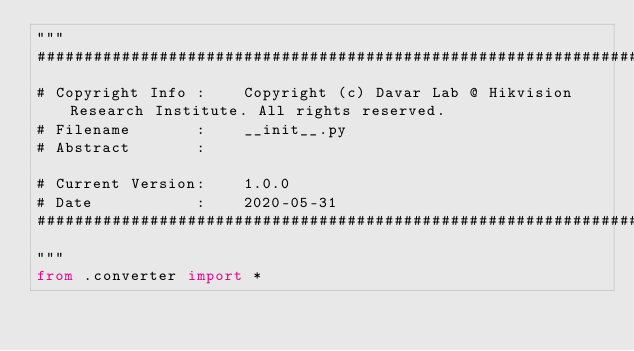<code> <loc_0><loc_0><loc_500><loc_500><_Python_>"""
##################################################################################################
# Copyright Info :    Copyright (c) Davar Lab @ Hikvision Research Institute. All rights reserved.
# Filename       :    __init__.py
# Abstract       :

# Current Version:    1.0.0
# Date           :    2020-05-31
##################################################################################################
"""
from .converter import *
</code> 